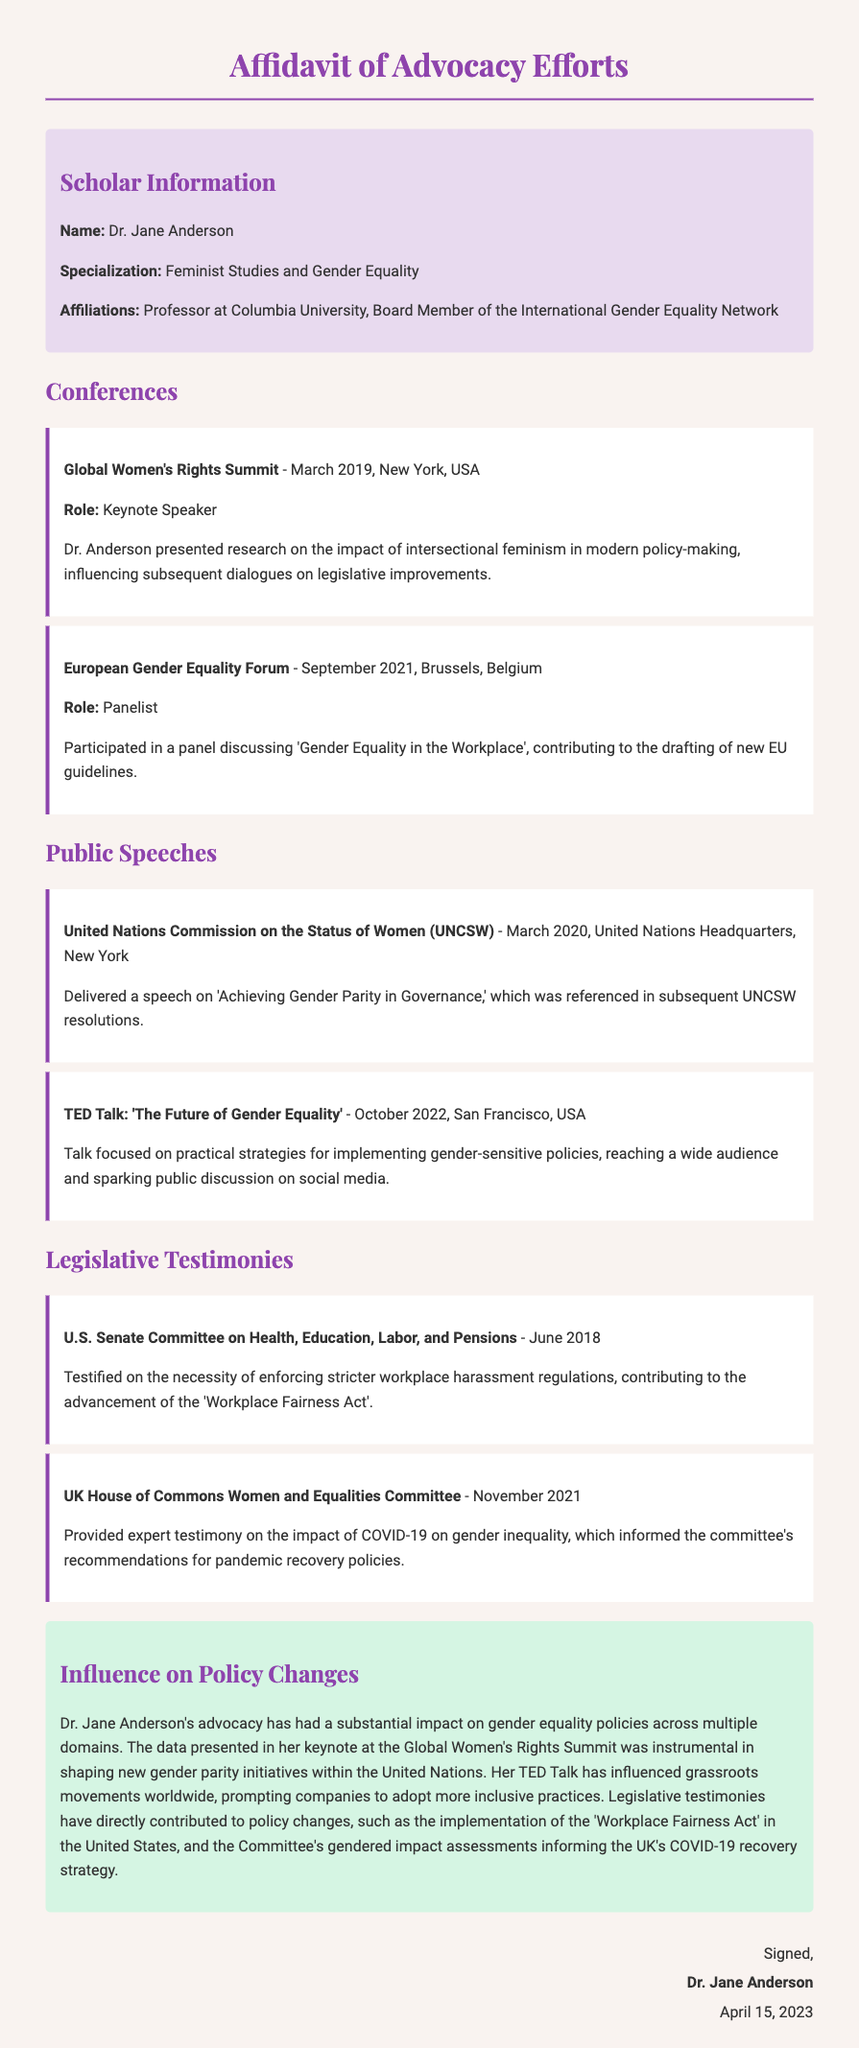What is the name of the scholar? The scholar's name is stated at the beginning of the document.
Answer: Dr. Jane Anderson What is Dr. Anderson's specialization? The specialization is mentioned in the scholar information section.
Answer: Feminist Studies and Gender Equality When did Dr. Anderson speak at the Global Women's Rights Summit? The date of the event is specified in the involvement section.
Answer: March 2019 What legislation did Dr. Anderson testify about in June 2018? The legislative testimony is detailed under the legislative testimonies section.
Answer: Workplace Fairness Act Which conference did Dr. Anderson participate in as a panelist? The specific role at the conference is mentioned in the involvement section.
Answer: European Gender Equality Forum What was the topic of Dr. Anderson's TED Talk? The topic of the talk is noted in the public speeches section.
Answer: The Future of Gender Equality Which organization referenced Dr. Anderson's speech in their resolutions? The referencing organization is included in the public speeches section.
Answer: United Nations Commission on the Status of Women How has Dr. Anderson's work influenced grassroots movements? The influence is summarized in the influence section, detailing the impact of her speech.
Answer: Prompting companies to adopt more inclusive practices In what year did Dr. Anderson provide testimony to the UK House of Commons? The year of the testimony is listed in the legislative testimonies section.
Answer: 2021 